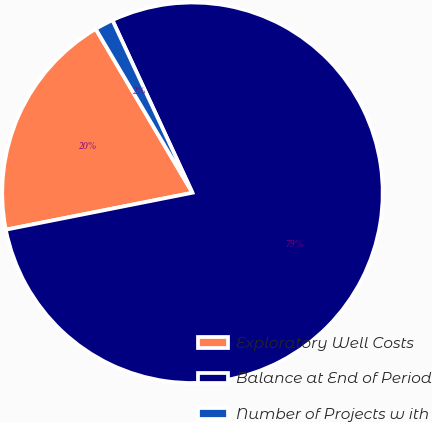<chart> <loc_0><loc_0><loc_500><loc_500><pie_chart><fcel>Exploratory Well Costs<fcel>Balance at End of Period<fcel>Number of Projects w ith<nl><fcel>19.62%<fcel>78.8%<fcel>1.58%<nl></chart> 